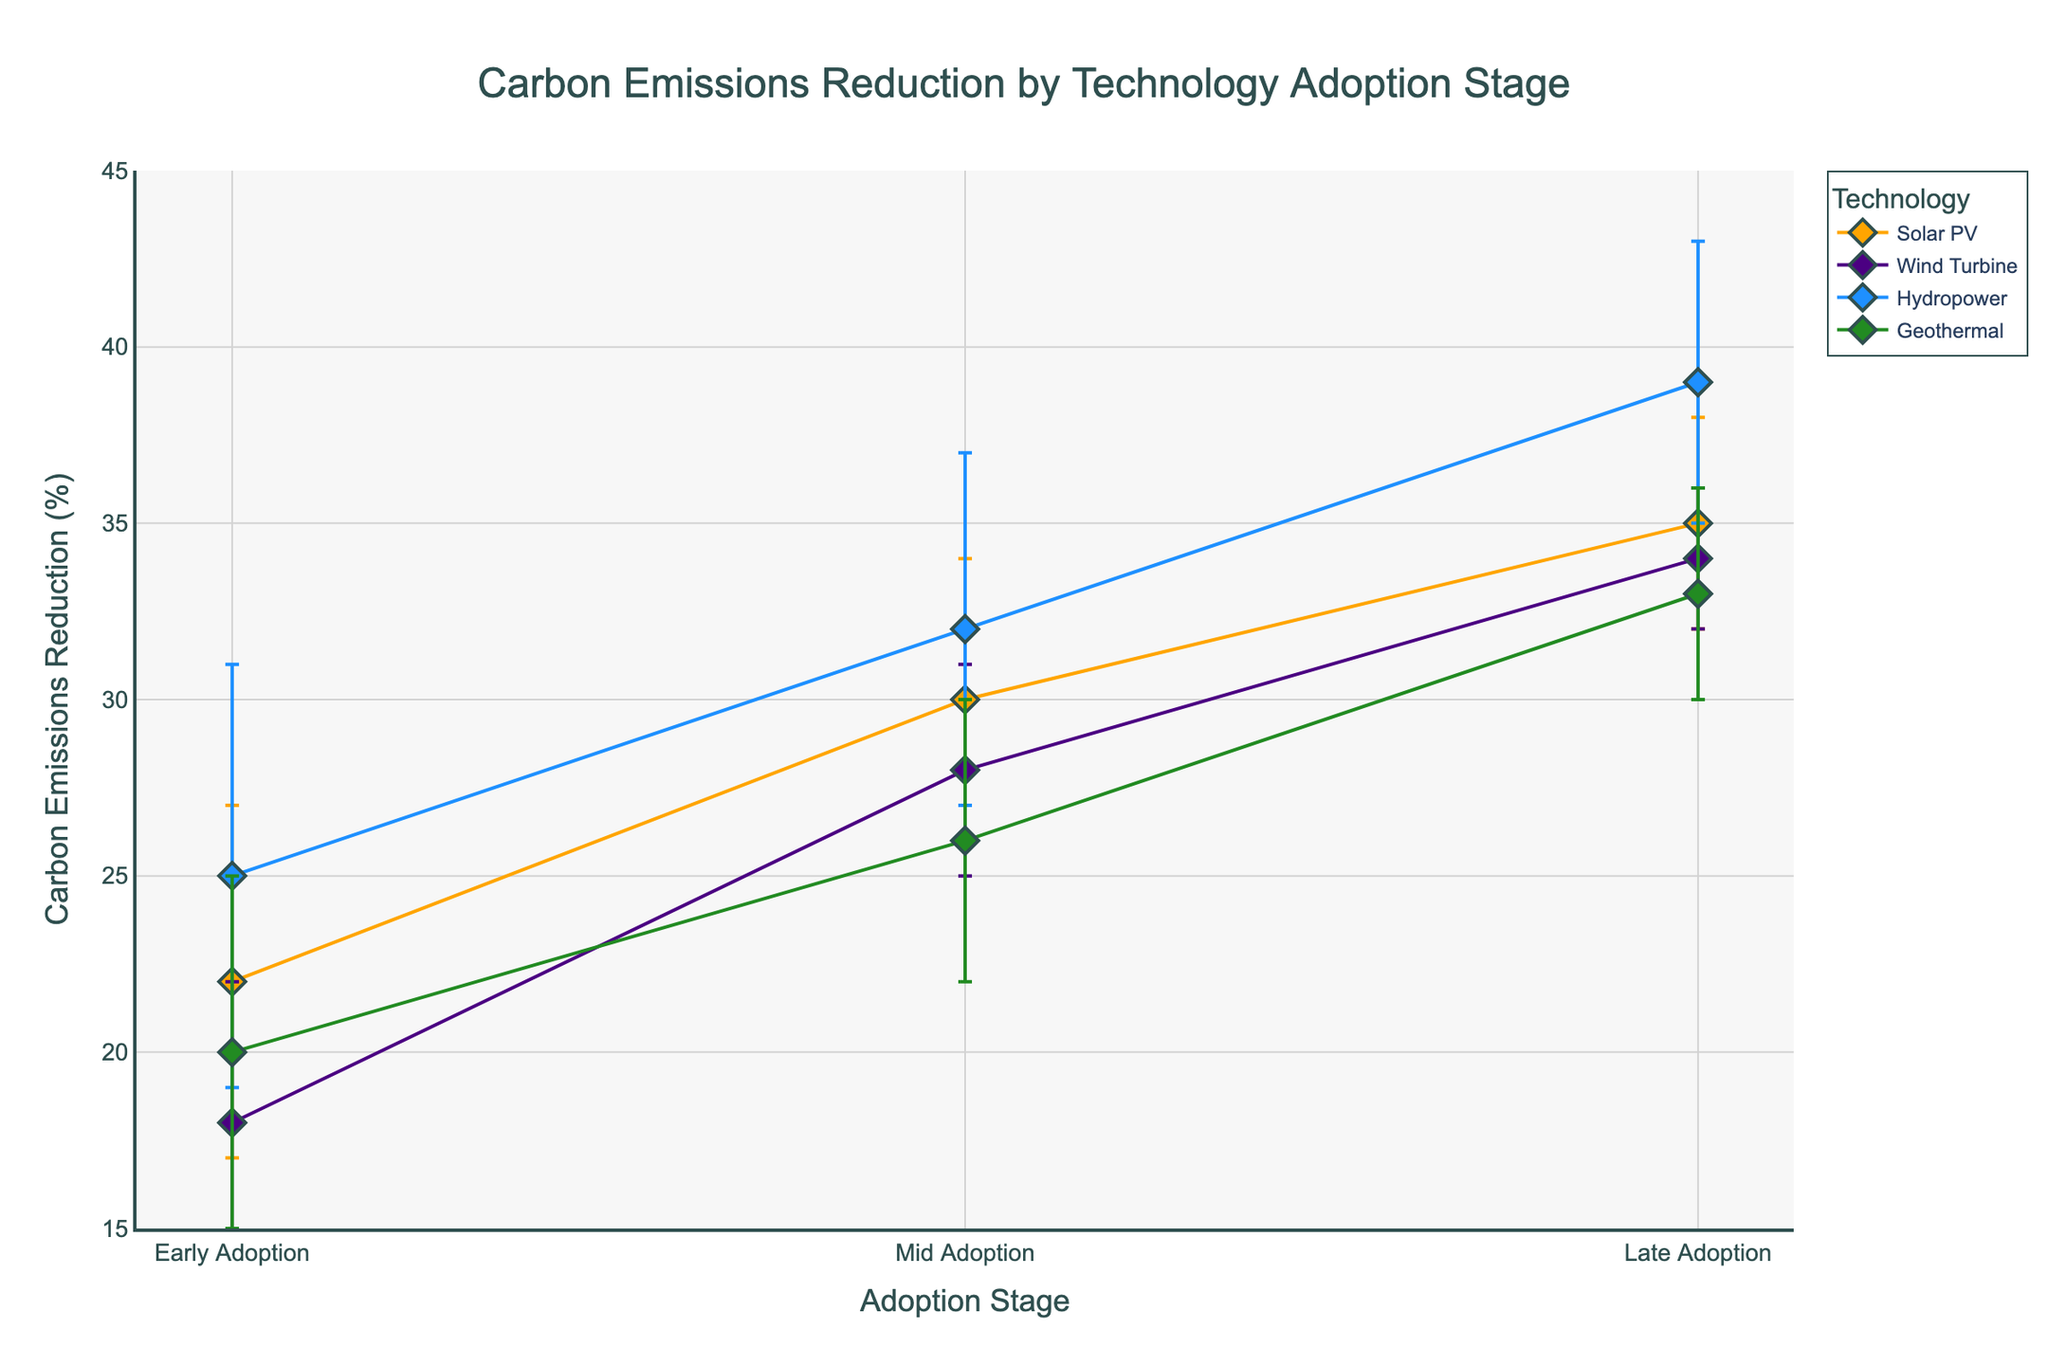Which technology shows the highest carbon emissions reduction at the Late Adoption stage? By examining the plot lines at the Late Adoption stage, we can see that Hydropower has the highest carbon emissions reduction value.
Answer: Hydropower What is the carbon emissions reduction for Solar PV during the Mid Adoption stage? The y-axis value for Solar PV at the Mid Adoption stage is 30%.
Answer: 30% Which technology has the lowest compliance variability at any stage? By looking at the error bars, Wind Turbine at the Late Adoption stage has the smallest error bar value, indicating the lowest compliance variability of 2%.
Answer: Wind Turbine How does the carbon emissions reduction for Wind Turbine compare from Early to Mid Adoption stage? Wind Turbine's carbon emissions reduction increases from 18% in the Early Adoption stage to 28% in the Mid Adoption stage. The difference is 10%.
Answer: 10% What's the average carbon emissions reduction across all stages for Geothermal? The average is calculated as (20 + 26 + 33) / 3 = 26.33%.
Answer: 26.33% Which technology has a consistent decrease in compliance variability from Early to Late Adoption stages? Solar PV shows a consistent decrease in compliance variability: from 5% in Early Adoption, 4% in Mid Adoption, to 3% in Late Adoption.
Answer: Solar PV If you combine the error margins of Solar PV and Hydropower at Late Adoption, what's their total variability? Summing the error bars for Solar PV (3%) and Hydropower (4%) at the Late Adoption stage gives a total of 3% + 4% = 7%.
Answer: 7% Which stage has the highest overall range of carbon emissions reductions for all technologies? The Late Adoption stage shows the highest range, from Wind Turbine's 34% to Hydropower's 39%.
Answer: Late Adoption Is there a technology that consistently improves its carbon emissions reduction and lowers its compliance variability over time? Geothermal shows a trend of increasing carbon emissions reduction from 20% to 33%, while compliance variability decreases from 5% to 3%.
Answer: Geothermal 